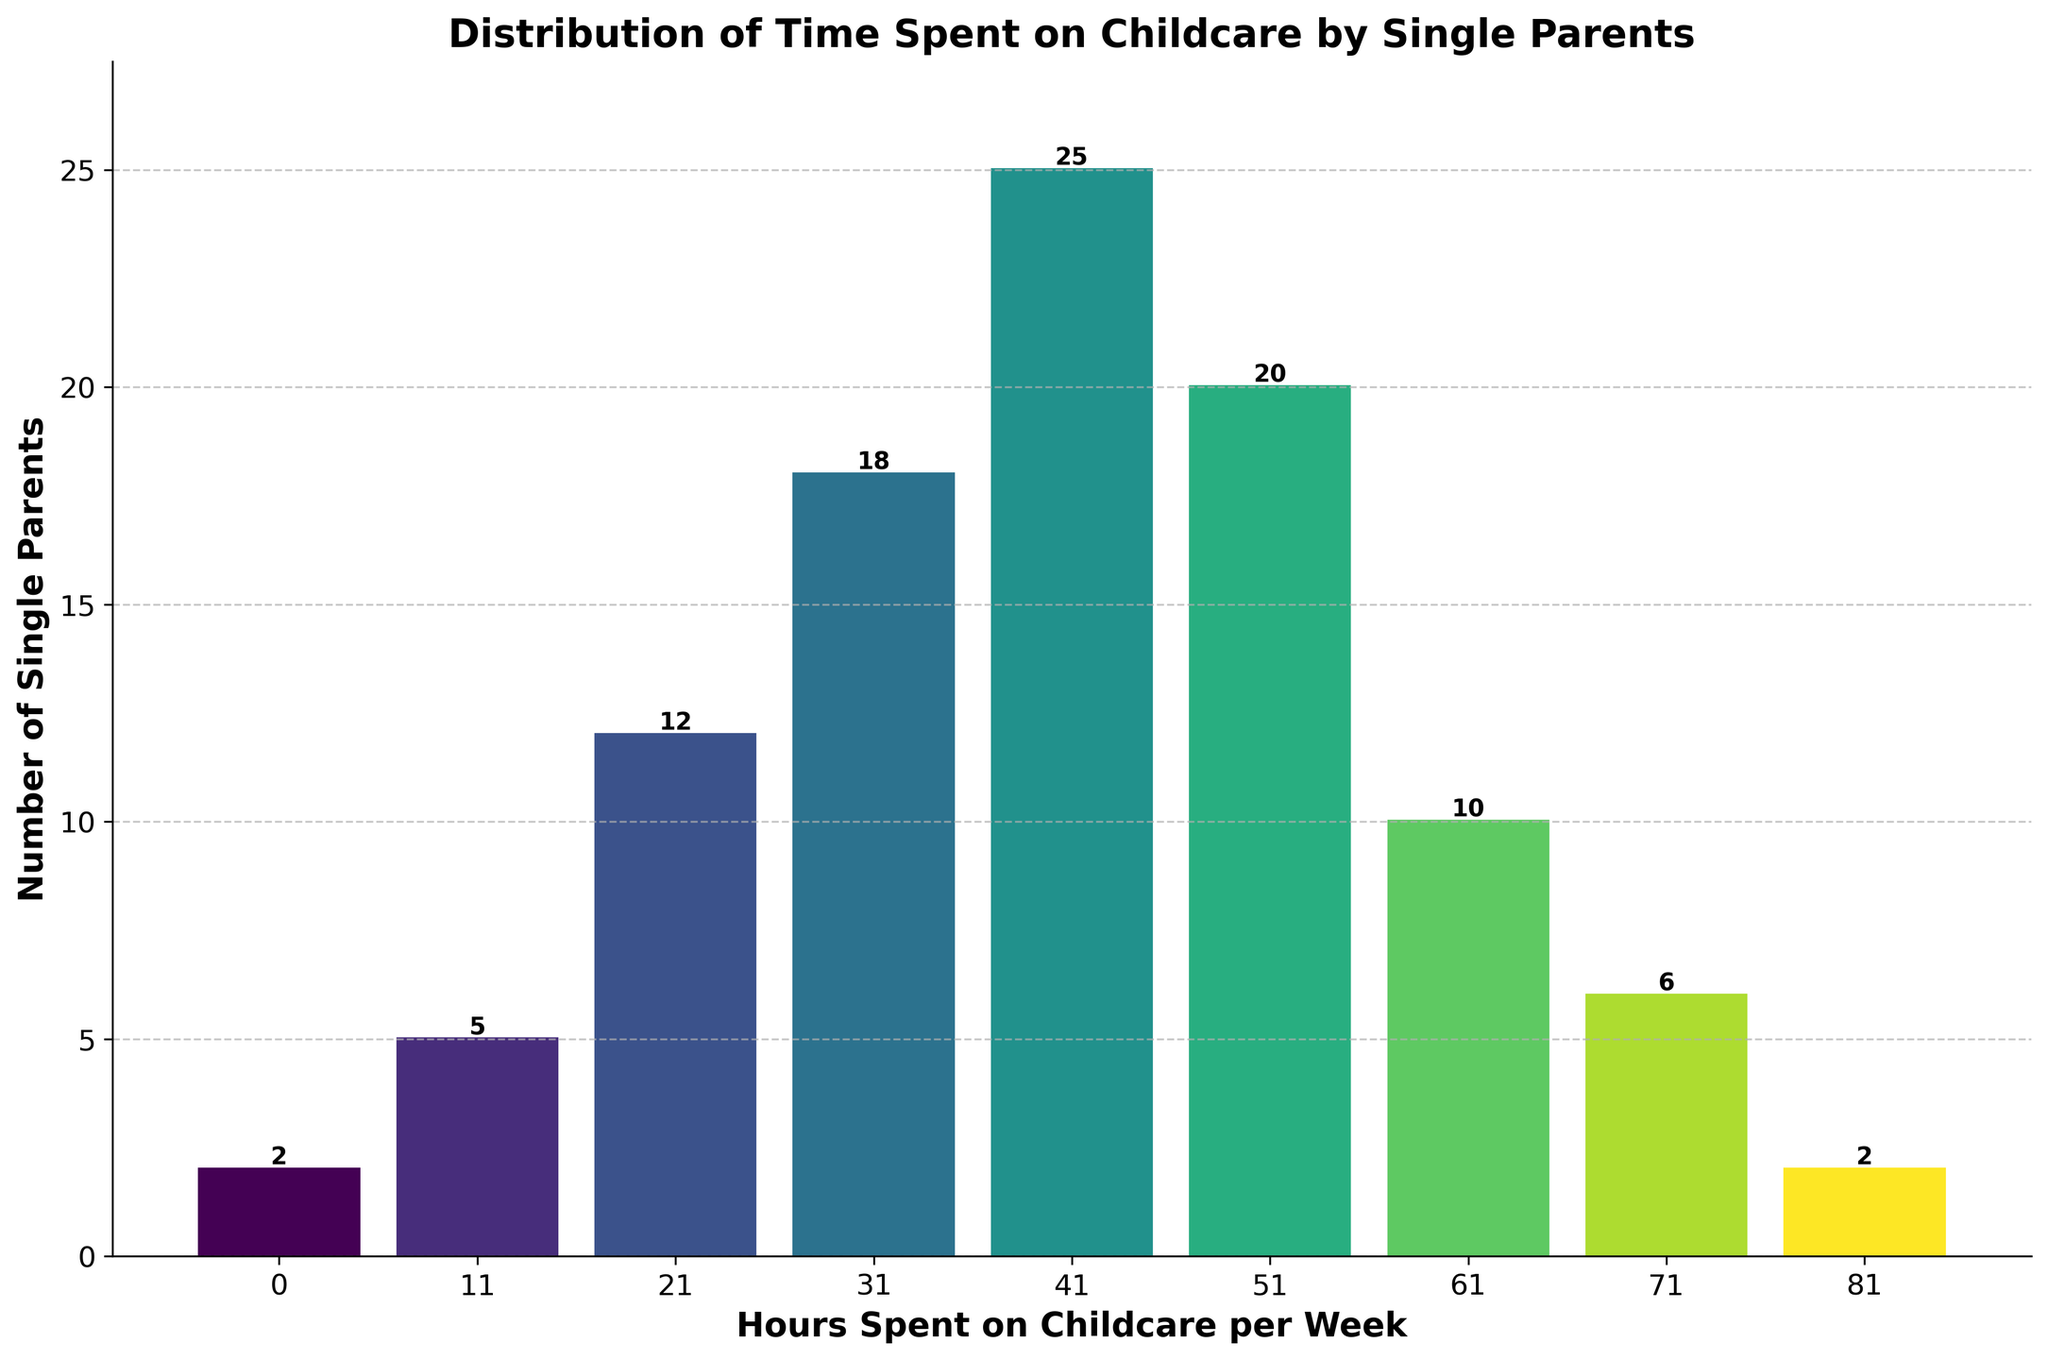What is the title of the figure? The title is typically placed at the top of the figure and describes what the figure is about. In this case, it is: "Distribution of Time Spent on Childcare by Single Parents."
Answer: Distribution of Time Spent on Childcare by Single Parents What does the x-axis represent? The x-axis label describes the information presented along the horizontal axis. Here, it represents "Hours Spent on Childcare per Week."
Answer: Hours Spent on Childcare per Week How many single parents spend between 41-50 hours on childcare per week? Look at the bar corresponding to the "41-50" hours range on the x-axis and read the height of the bar, as indicated by the number above it.
Answer: 25 Which range has the highest number of single parents? Compare the heights of all the bars and identify the bar that is tallest. The "41-50" hours range has the tallest bar indicating the highest number of single parents.
Answer: 41-50 hours How many single parents spend more than 60 hours on childcare per week? Sum the frequencies of the bars to the right of the "61-70" hours range. These are the ranges "61-70," "71-80," and "81-90" hours: 10 + 6 + 2 = 18.
Answer: 18 What is the frequency of single parents spending 21-30 hours on childcare per week? Refer to the bar labeled "21-30" hours and read the number directly above it.
Answer: 12 Are there any ranges with a frequency of exactly 2? Check the numbers above each bar to see which ones have a frequency of 2. The ranges "0-10" and "81-90" hours each have a frequency of 2.
Answer: Yes How many single parents spend between 31-60 hours on childcare per week? Sum the frequencies of the bars within the ranges "31-40," "41-50," and "51-60" hours: 18 + 25 + 20 = 63.
Answer: 63 How many hours per week do most single parents spend on childcare? The range with the tallest bar indicates where most single parents fall. Here, it is the "41-50" hour range.
Answer: 41-50 hours Which range has the lowest number of single parents and how many are there? Identify the shortest bar. There are two bars with the shortest height of 2 single parents each: "0-10" and "81-90" hours ranges.
Answer: 0-10 and 81-90 hours, 2 